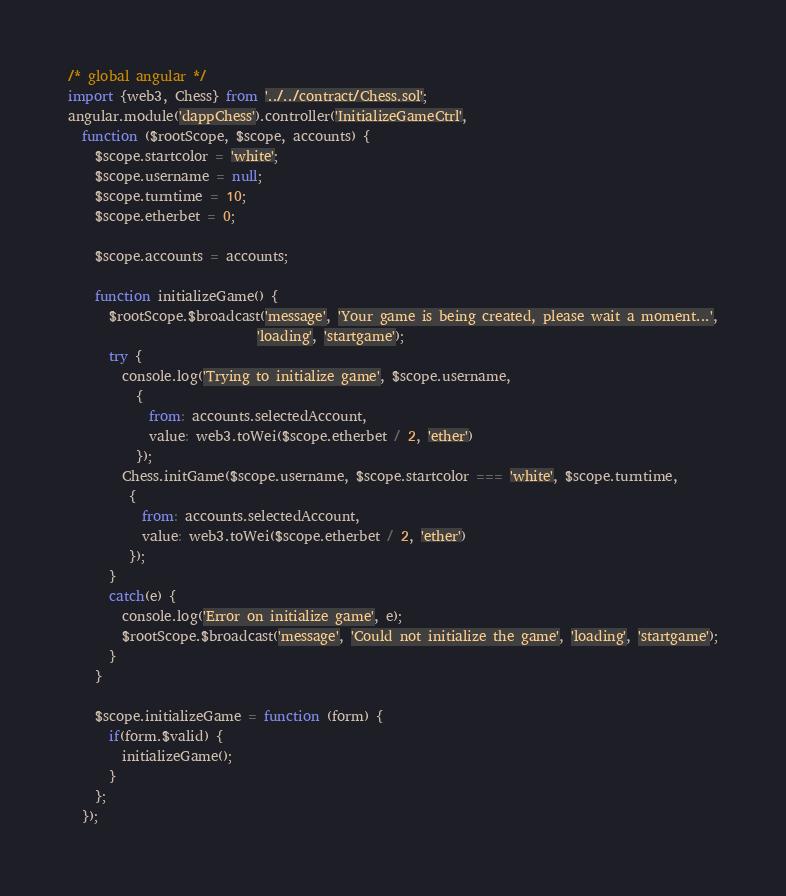<code> <loc_0><loc_0><loc_500><loc_500><_JavaScript_>/* global angular */
import {web3, Chess} from '../../contract/Chess.sol';
angular.module('dappChess').controller('InitializeGameCtrl',
  function ($rootScope, $scope, accounts) {
    $scope.startcolor = 'white';
    $scope.username = null;
    $scope.turntime = 10;
    $scope.etherbet = 0;

    $scope.accounts = accounts;

    function initializeGame() {
      $rootScope.$broadcast('message', 'Your game is being created, please wait a moment...',
                            'loading', 'startgame');
      try {
        console.log('Trying to initialize game', $scope.username,
          {
            from: accounts.selectedAccount,
            value: web3.toWei($scope.etherbet / 2, 'ether')
          });
        Chess.initGame($scope.username, $scope.startcolor === 'white', $scope.turntime,
         {
           from: accounts.selectedAccount,
           value: web3.toWei($scope.etherbet / 2, 'ether')
         });
      }
      catch(e) {
        console.log('Error on initialize game', e);
        $rootScope.$broadcast('message', 'Could not initialize the game', 'loading', 'startgame');
      }
    }

    $scope.initializeGame = function (form) {
      if(form.$valid) {
        initializeGame();
      }
    };
  });
</code> 